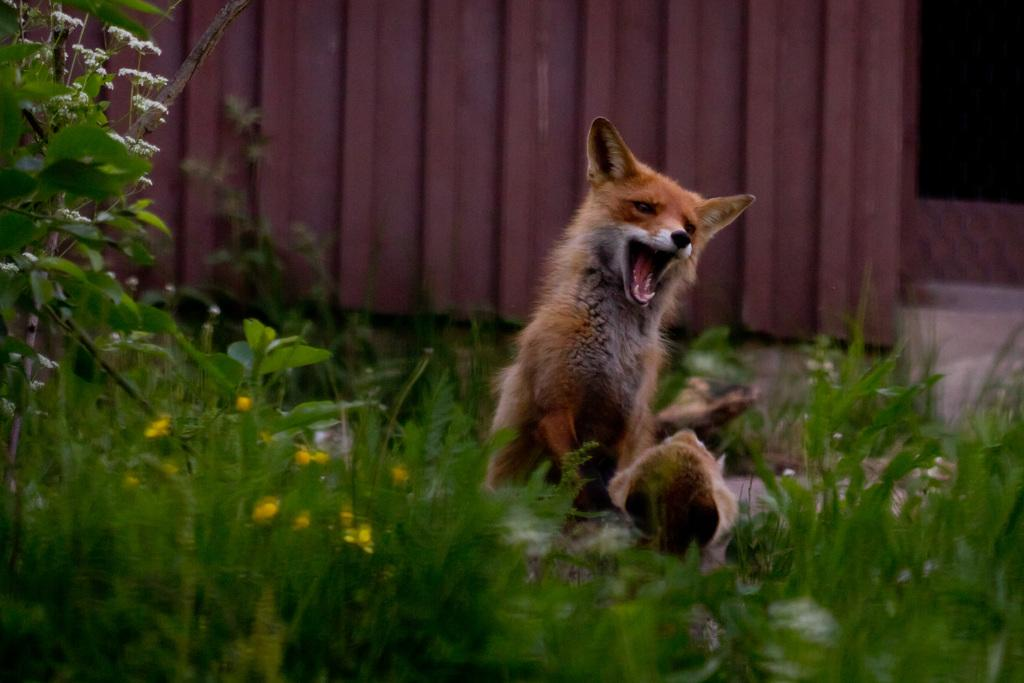What type of animal is in the image? There is a dog in the image. What is the dog doing in the image? The dog is standing on the ground. What can be seen in the background of the image? There are flower plants and a door in the background of the image. What holiday is being celebrated in the image? There is no indication of a holiday being celebrated in the image. What type of animal is starting a race in the image? There is no race or animal starting a race in the image; it features a dog standing on the ground. 